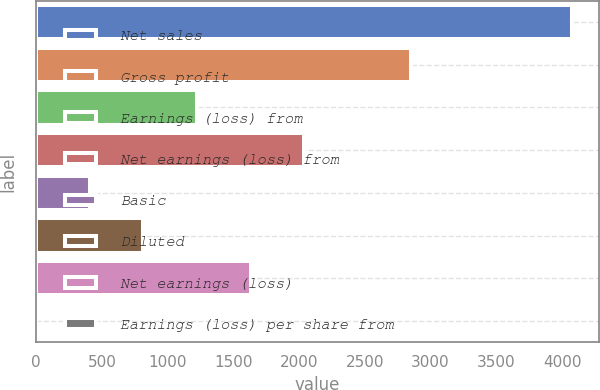<chart> <loc_0><loc_0><loc_500><loc_500><bar_chart><fcel>Net sales<fcel>Gross profit<fcel>Earnings (loss) from<fcel>Net earnings (loss) from<fcel>Basic<fcel>Diluted<fcel>Net earnings (loss)<fcel>Earnings (loss) per share from<nl><fcel>4076.1<fcel>2853.39<fcel>1223.07<fcel>2038.23<fcel>407.91<fcel>815.49<fcel>1630.65<fcel>0.33<nl></chart> 